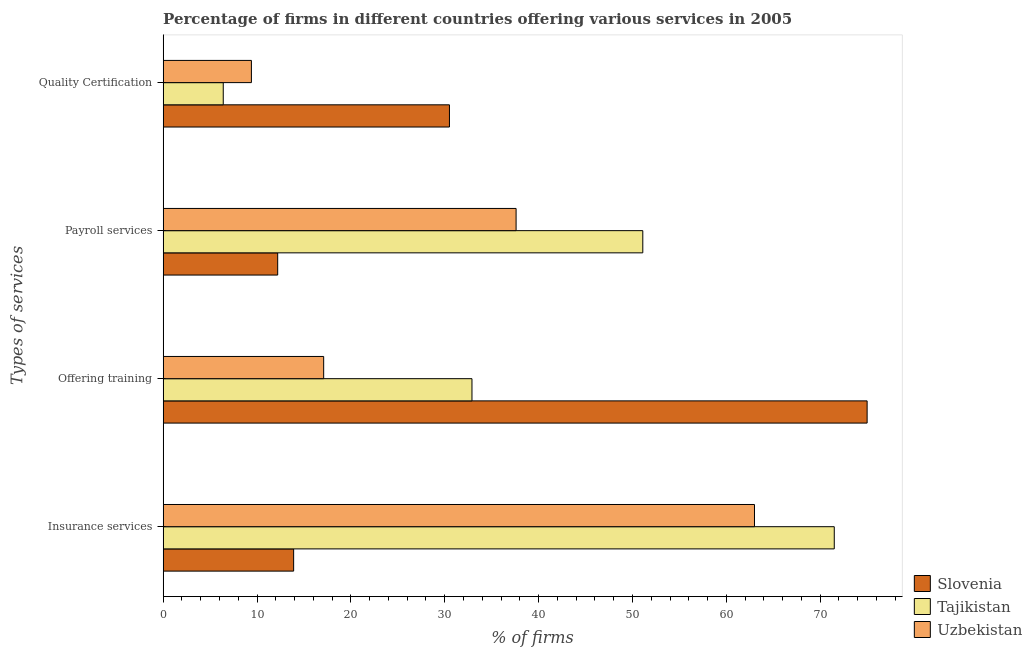How many groups of bars are there?
Your answer should be compact. 4. Are the number of bars per tick equal to the number of legend labels?
Your response must be concise. Yes. Are the number of bars on each tick of the Y-axis equal?
Provide a succinct answer. Yes. How many bars are there on the 2nd tick from the bottom?
Provide a succinct answer. 3. What is the label of the 3rd group of bars from the top?
Your answer should be very brief. Offering training. What is the percentage of firms offering training in Slovenia?
Offer a terse response. 75. Across all countries, what is the minimum percentage of firms offering training?
Make the answer very short. 17.1. In which country was the percentage of firms offering payroll services maximum?
Offer a very short reply. Tajikistan. In which country was the percentage of firms offering quality certification minimum?
Keep it short and to the point. Tajikistan. What is the total percentage of firms offering payroll services in the graph?
Provide a succinct answer. 100.9. What is the difference between the percentage of firms offering payroll services in Tajikistan and that in Uzbekistan?
Provide a succinct answer. 13.5. What is the difference between the percentage of firms offering quality certification in Slovenia and the percentage of firms offering insurance services in Uzbekistan?
Keep it short and to the point. -32.5. What is the average percentage of firms offering training per country?
Keep it short and to the point. 41.67. What is the difference between the percentage of firms offering quality certification and percentage of firms offering insurance services in Tajikistan?
Your response must be concise. -65.1. What is the ratio of the percentage of firms offering quality certification in Uzbekistan to that in Slovenia?
Provide a succinct answer. 0.31. Is the percentage of firms offering training in Tajikistan less than that in Slovenia?
Provide a short and direct response. Yes. Is the difference between the percentage of firms offering training in Uzbekistan and Slovenia greater than the difference between the percentage of firms offering payroll services in Uzbekistan and Slovenia?
Your response must be concise. No. What is the difference between the highest and the lowest percentage of firms offering quality certification?
Provide a short and direct response. 24.1. What does the 1st bar from the top in Payroll services represents?
Your response must be concise. Uzbekistan. What does the 3rd bar from the bottom in Insurance services represents?
Provide a succinct answer. Uzbekistan. How many countries are there in the graph?
Give a very brief answer. 3. What is the difference between two consecutive major ticks on the X-axis?
Ensure brevity in your answer.  10. Are the values on the major ticks of X-axis written in scientific E-notation?
Your response must be concise. No. Does the graph contain any zero values?
Provide a short and direct response. No. Does the graph contain grids?
Give a very brief answer. No. Where does the legend appear in the graph?
Your response must be concise. Bottom right. How many legend labels are there?
Keep it short and to the point. 3. How are the legend labels stacked?
Provide a succinct answer. Vertical. What is the title of the graph?
Your answer should be compact. Percentage of firms in different countries offering various services in 2005. What is the label or title of the X-axis?
Ensure brevity in your answer.  % of firms. What is the label or title of the Y-axis?
Offer a terse response. Types of services. What is the % of firms of Slovenia in Insurance services?
Keep it short and to the point. 13.9. What is the % of firms of Tajikistan in Insurance services?
Ensure brevity in your answer.  71.5. What is the % of firms of Slovenia in Offering training?
Your response must be concise. 75. What is the % of firms of Tajikistan in Offering training?
Keep it short and to the point. 32.9. What is the % of firms of Slovenia in Payroll services?
Make the answer very short. 12.2. What is the % of firms of Tajikistan in Payroll services?
Provide a short and direct response. 51.1. What is the % of firms of Uzbekistan in Payroll services?
Provide a short and direct response. 37.6. What is the % of firms in Slovenia in Quality Certification?
Offer a terse response. 30.5. What is the % of firms in Uzbekistan in Quality Certification?
Offer a very short reply. 9.4. Across all Types of services, what is the maximum % of firms in Slovenia?
Ensure brevity in your answer.  75. Across all Types of services, what is the maximum % of firms of Tajikistan?
Provide a short and direct response. 71.5. Across all Types of services, what is the maximum % of firms of Uzbekistan?
Your response must be concise. 63. What is the total % of firms of Slovenia in the graph?
Offer a very short reply. 131.6. What is the total % of firms of Tajikistan in the graph?
Your answer should be compact. 161.9. What is the total % of firms in Uzbekistan in the graph?
Give a very brief answer. 127.1. What is the difference between the % of firms in Slovenia in Insurance services and that in Offering training?
Your answer should be very brief. -61.1. What is the difference between the % of firms in Tajikistan in Insurance services and that in Offering training?
Provide a succinct answer. 38.6. What is the difference between the % of firms of Uzbekistan in Insurance services and that in Offering training?
Provide a succinct answer. 45.9. What is the difference between the % of firms of Slovenia in Insurance services and that in Payroll services?
Make the answer very short. 1.7. What is the difference between the % of firms in Tajikistan in Insurance services and that in Payroll services?
Offer a very short reply. 20.4. What is the difference between the % of firms of Uzbekistan in Insurance services and that in Payroll services?
Give a very brief answer. 25.4. What is the difference between the % of firms in Slovenia in Insurance services and that in Quality Certification?
Provide a succinct answer. -16.6. What is the difference between the % of firms of Tajikistan in Insurance services and that in Quality Certification?
Your answer should be very brief. 65.1. What is the difference between the % of firms in Uzbekistan in Insurance services and that in Quality Certification?
Ensure brevity in your answer.  53.6. What is the difference between the % of firms in Slovenia in Offering training and that in Payroll services?
Keep it short and to the point. 62.8. What is the difference between the % of firms of Tajikistan in Offering training and that in Payroll services?
Make the answer very short. -18.2. What is the difference between the % of firms of Uzbekistan in Offering training and that in Payroll services?
Offer a very short reply. -20.5. What is the difference between the % of firms of Slovenia in Offering training and that in Quality Certification?
Keep it short and to the point. 44.5. What is the difference between the % of firms in Uzbekistan in Offering training and that in Quality Certification?
Provide a short and direct response. 7.7. What is the difference between the % of firms in Slovenia in Payroll services and that in Quality Certification?
Ensure brevity in your answer.  -18.3. What is the difference between the % of firms in Tajikistan in Payroll services and that in Quality Certification?
Ensure brevity in your answer.  44.7. What is the difference between the % of firms in Uzbekistan in Payroll services and that in Quality Certification?
Ensure brevity in your answer.  28.2. What is the difference between the % of firms in Slovenia in Insurance services and the % of firms in Uzbekistan in Offering training?
Provide a short and direct response. -3.2. What is the difference between the % of firms in Tajikistan in Insurance services and the % of firms in Uzbekistan in Offering training?
Provide a succinct answer. 54.4. What is the difference between the % of firms of Slovenia in Insurance services and the % of firms of Tajikistan in Payroll services?
Your answer should be very brief. -37.2. What is the difference between the % of firms of Slovenia in Insurance services and the % of firms of Uzbekistan in Payroll services?
Your answer should be compact. -23.7. What is the difference between the % of firms of Tajikistan in Insurance services and the % of firms of Uzbekistan in Payroll services?
Your answer should be very brief. 33.9. What is the difference between the % of firms of Tajikistan in Insurance services and the % of firms of Uzbekistan in Quality Certification?
Make the answer very short. 62.1. What is the difference between the % of firms of Slovenia in Offering training and the % of firms of Tajikistan in Payroll services?
Offer a very short reply. 23.9. What is the difference between the % of firms of Slovenia in Offering training and the % of firms of Uzbekistan in Payroll services?
Your answer should be very brief. 37.4. What is the difference between the % of firms in Tajikistan in Offering training and the % of firms in Uzbekistan in Payroll services?
Your answer should be compact. -4.7. What is the difference between the % of firms of Slovenia in Offering training and the % of firms of Tajikistan in Quality Certification?
Keep it short and to the point. 68.6. What is the difference between the % of firms of Slovenia in Offering training and the % of firms of Uzbekistan in Quality Certification?
Your answer should be very brief. 65.6. What is the difference between the % of firms in Tajikistan in Offering training and the % of firms in Uzbekistan in Quality Certification?
Keep it short and to the point. 23.5. What is the difference between the % of firms of Slovenia in Payroll services and the % of firms of Tajikistan in Quality Certification?
Provide a short and direct response. 5.8. What is the difference between the % of firms of Slovenia in Payroll services and the % of firms of Uzbekistan in Quality Certification?
Your answer should be very brief. 2.8. What is the difference between the % of firms in Tajikistan in Payroll services and the % of firms in Uzbekistan in Quality Certification?
Your response must be concise. 41.7. What is the average % of firms of Slovenia per Types of services?
Offer a terse response. 32.9. What is the average % of firms of Tajikistan per Types of services?
Your answer should be compact. 40.48. What is the average % of firms of Uzbekistan per Types of services?
Make the answer very short. 31.77. What is the difference between the % of firms in Slovenia and % of firms in Tajikistan in Insurance services?
Give a very brief answer. -57.6. What is the difference between the % of firms of Slovenia and % of firms of Uzbekistan in Insurance services?
Ensure brevity in your answer.  -49.1. What is the difference between the % of firms of Tajikistan and % of firms of Uzbekistan in Insurance services?
Keep it short and to the point. 8.5. What is the difference between the % of firms of Slovenia and % of firms of Tajikistan in Offering training?
Offer a very short reply. 42.1. What is the difference between the % of firms in Slovenia and % of firms in Uzbekistan in Offering training?
Offer a very short reply. 57.9. What is the difference between the % of firms in Slovenia and % of firms in Tajikistan in Payroll services?
Ensure brevity in your answer.  -38.9. What is the difference between the % of firms of Slovenia and % of firms of Uzbekistan in Payroll services?
Provide a short and direct response. -25.4. What is the difference between the % of firms of Slovenia and % of firms of Tajikistan in Quality Certification?
Offer a terse response. 24.1. What is the difference between the % of firms of Slovenia and % of firms of Uzbekistan in Quality Certification?
Provide a succinct answer. 21.1. What is the difference between the % of firms in Tajikistan and % of firms in Uzbekistan in Quality Certification?
Provide a short and direct response. -3. What is the ratio of the % of firms of Slovenia in Insurance services to that in Offering training?
Offer a very short reply. 0.19. What is the ratio of the % of firms in Tajikistan in Insurance services to that in Offering training?
Give a very brief answer. 2.17. What is the ratio of the % of firms of Uzbekistan in Insurance services to that in Offering training?
Ensure brevity in your answer.  3.68. What is the ratio of the % of firms of Slovenia in Insurance services to that in Payroll services?
Your response must be concise. 1.14. What is the ratio of the % of firms of Tajikistan in Insurance services to that in Payroll services?
Offer a very short reply. 1.4. What is the ratio of the % of firms of Uzbekistan in Insurance services to that in Payroll services?
Ensure brevity in your answer.  1.68. What is the ratio of the % of firms of Slovenia in Insurance services to that in Quality Certification?
Make the answer very short. 0.46. What is the ratio of the % of firms in Tajikistan in Insurance services to that in Quality Certification?
Provide a succinct answer. 11.17. What is the ratio of the % of firms in Uzbekistan in Insurance services to that in Quality Certification?
Give a very brief answer. 6.7. What is the ratio of the % of firms in Slovenia in Offering training to that in Payroll services?
Ensure brevity in your answer.  6.15. What is the ratio of the % of firms in Tajikistan in Offering training to that in Payroll services?
Your answer should be very brief. 0.64. What is the ratio of the % of firms in Uzbekistan in Offering training to that in Payroll services?
Offer a terse response. 0.45. What is the ratio of the % of firms of Slovenia in Offering training to that in Quality Certification?
Your answer should be compact. 2.46. What is the ratio of the % of firms of Tajikistan in Offering training to that in Quality Certification?
Keep it short and to the point. 5.14. What is the ratio of the % of firms of Uzbekistan in Offering training to that in Quality Certification?
Your answer should be very brief. 1.82. What is the ratio of the % of firms of Slovenia in Payroll services to that in Quality Certification?
Offer a very short reply. 0.4. What is the ratio of the % of firms in Tajikistan in Payroll services to that in Quality Certification?
Your answer should be very brief. 7.98. What is the difference between the highest and the second highest % of firms of Slovenia?
Keep it short and to the point. 44.5. What is the difference between the highest and the second highest % of firms of Tajikistan?
Make the answer very short. 20.4. What is the difference between the highest and the second highest % of firms in Uzbekistan?
Offer a very short reply. 25.4. What is the difference between the highest and the lowest % of firms in Slovenia?
Give a very brief answer. 62.8. What is the difference between the highest and the lowest % of firms of Tajikistan?
Offer a very short reply. 65.1. What is the difference between the highest and the lowest % of firms in Uzbekistan?
Give a very brief answer. 53.6. 